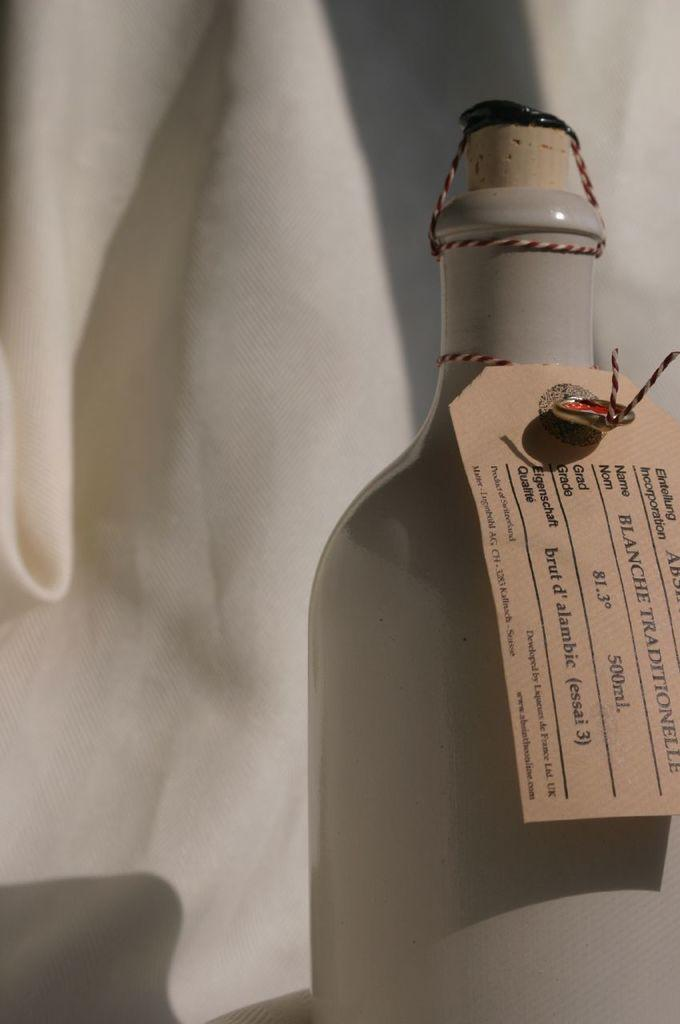<image>
Summarize the visual content of the image. A grey bottle has a tag on it that says Blanche Traditionelle. 